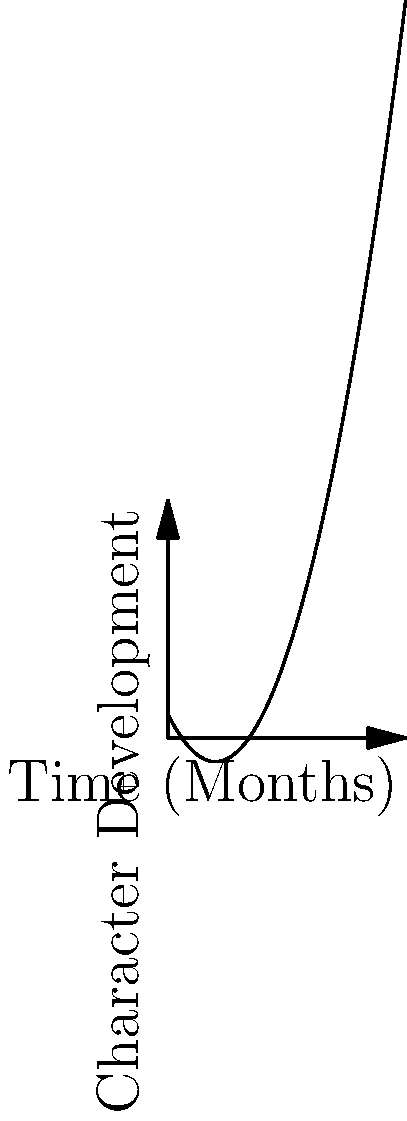Analyzing the character development arc of Daniel LaRusso in "The Karate Kid," as depicted in the line graph, which cinematic technique most effectively reinforces the visual representation of his growth from the "Meeting Mr. Miyagi" point to the "Tournament" climax? To answer this question, we need to consider the following steps:

1. Observe the graph: The line shows a clear upward trajectory, indicating Daniel's growth throughout the movie.

2. Identify key points: The graph highlights four significant moments in Daniel's journey: Meeting Mr. Miyagi, Wax On/Wax Off training, mastering the Crane Kick, and the Tournament.

3. Analyze the curve: The steepness increases as we move from left to right, suggesting accelerated character development.

4. Consider cinematic techniques: 
   a) Montage sequences
   b) Close-up shots
   c) Dialogue-driven scenes
   d) Visual metaphors

5. Match techniques to graph progression:
   - Montage sequences effectively compress time and show rapid skill acquisition, aligning with the graph's accelerating curve.
   - Close-ups might emphasize emotional growth but don't necessarily convey the passage of time or skill development as clearly.
   - Dialogue-driven scenes could explain character motivation but might not visually represent the growth as dynamically.
   - Visual metaphors (like the balance exercises) contribute to character development but are more specific moments rather than an overarching technique.

6. Conclusion: The montage technique, exemplified by the famous training sequences, best reinforces the visual representation of Daniel's growth curve as shown in the graph.
Answer: Montage sequences 